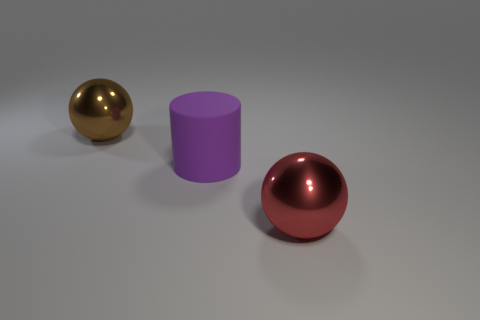Subtract all spheres. How many objects are left? 1 Add 3 large purple metallic balls. How many objects exist? 6 Add 1 balls. How many balls are left? 3 Add 1 big brown spheres. How many big brown spheres exist? 2 Subtract 0 red cubes. How many objects are left? 3 Subtract all blue things. Subtract all brown balls. How many objects are left? 2 